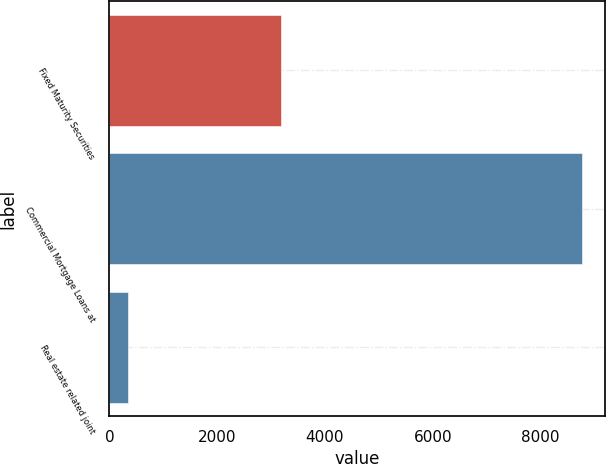<chart> <loc_0><loc_0><loc_500><loc_500><bar_chart><fcel>Fixed Maturity Securities<fcel>Commercial Mortgage Loans at<fcel>Real estate related joint<nl><fcel>3188<fcel>8765<fcel>348<nl></chart> 